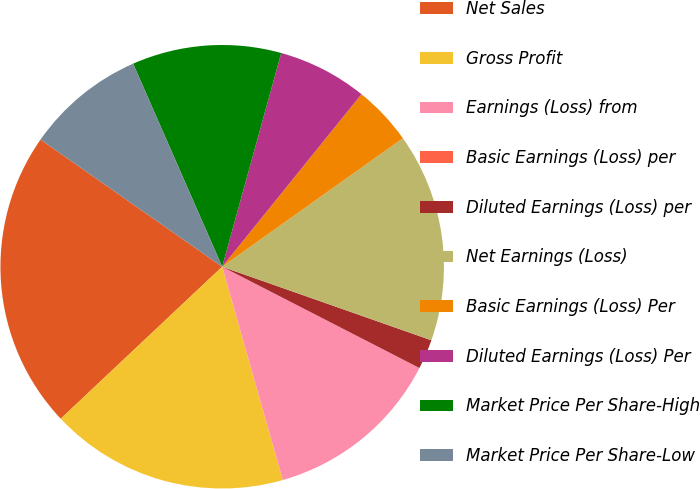Convert chart. <chart><loc_0><loc_0><loc_500><loc_500><pie_chart><fcel>Net Sales<fcel>Gross Profit<fcel>Earnings (Loss) from<fcel>Basic Earnings (Loss) per<fcel>Diluted Earnings (Loss) per<fcel>Net Earnings (Loss)<fcel>Basic Earnings (Loss) Per<fcel>Diluted Earnings (Loss) Per<fcel>Market Price Per Share-High<fcel>Market Price Per Share-Low<nl><fcel>21.74%<fcel>17.39%<fcel>13.04%<fcel>0.0%<fcel>2.17%<fcel>15.22%<fcel>4.35%<fcel>6.52%<fcel>10.87%<fcel>8.7%<nl></chart> 